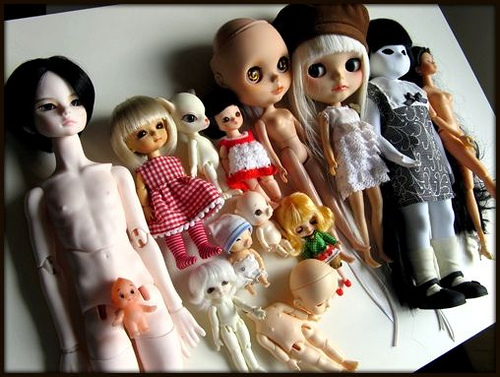<image>
Can you confirm if the cat doll is above the pink dress? No. The cat doll is not positioned above the pink dress. The vertical arrangement shows a different relationship. Is the toy to the left of the toy? Yes. From this viewpoint, the toy is positioned to the left side relative to the toy. 